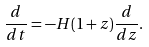<formula> <loc_0><loc_0><loc_500><loc_500>\frac { d } { d t } = - H ( 1 + z ) \frac { d } { d z } .</formula> 